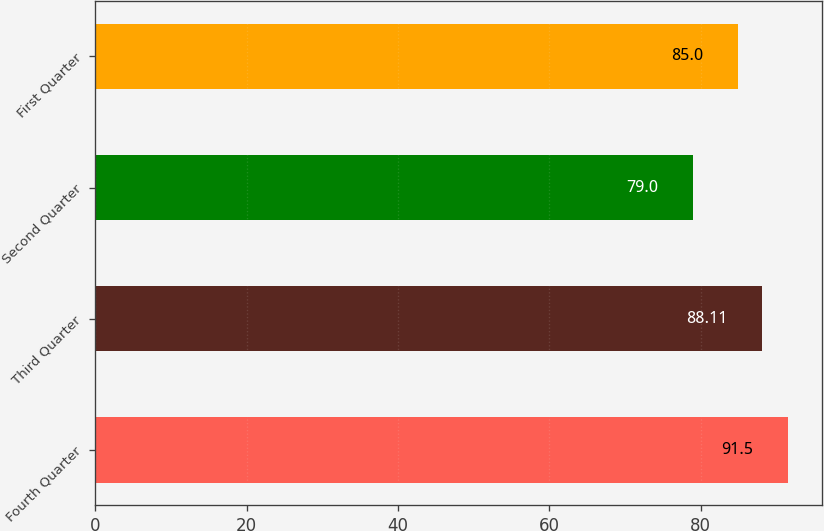Convert chart. <chart><loc_0><loc_0><loc_500><loc_500><bar_chart><fcel>Fourth Quarter<fcel>Third Quarter<fcel>Second Quarter<fcel>First Quarter<nl><fcel>91.5<fcel>88.11<fcel>79<fcel>85<nl></chart> 